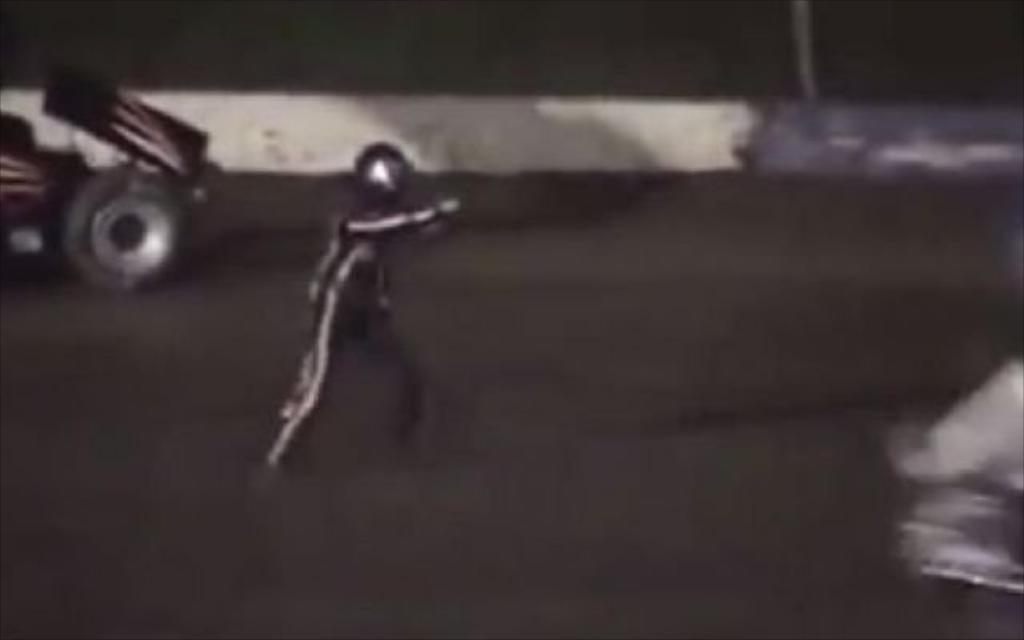What is the main subject of the image? There is a person standing in the image. What is the person standing on? The person is standing on a surface. What else can be seen in the image besides the person? There is a vehicle in the image. How many apples are on the plant in the image? There is no plant or apples present in the image. What is the person's afterthought while standing in the image? The provided facts do not give any information about the person's thoughts or feelings, so we cannot determine their afterthought. 